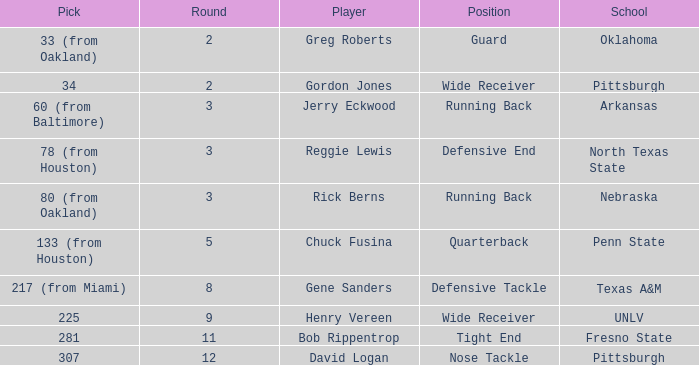In which round was the nose tackle selected? 12.0. 